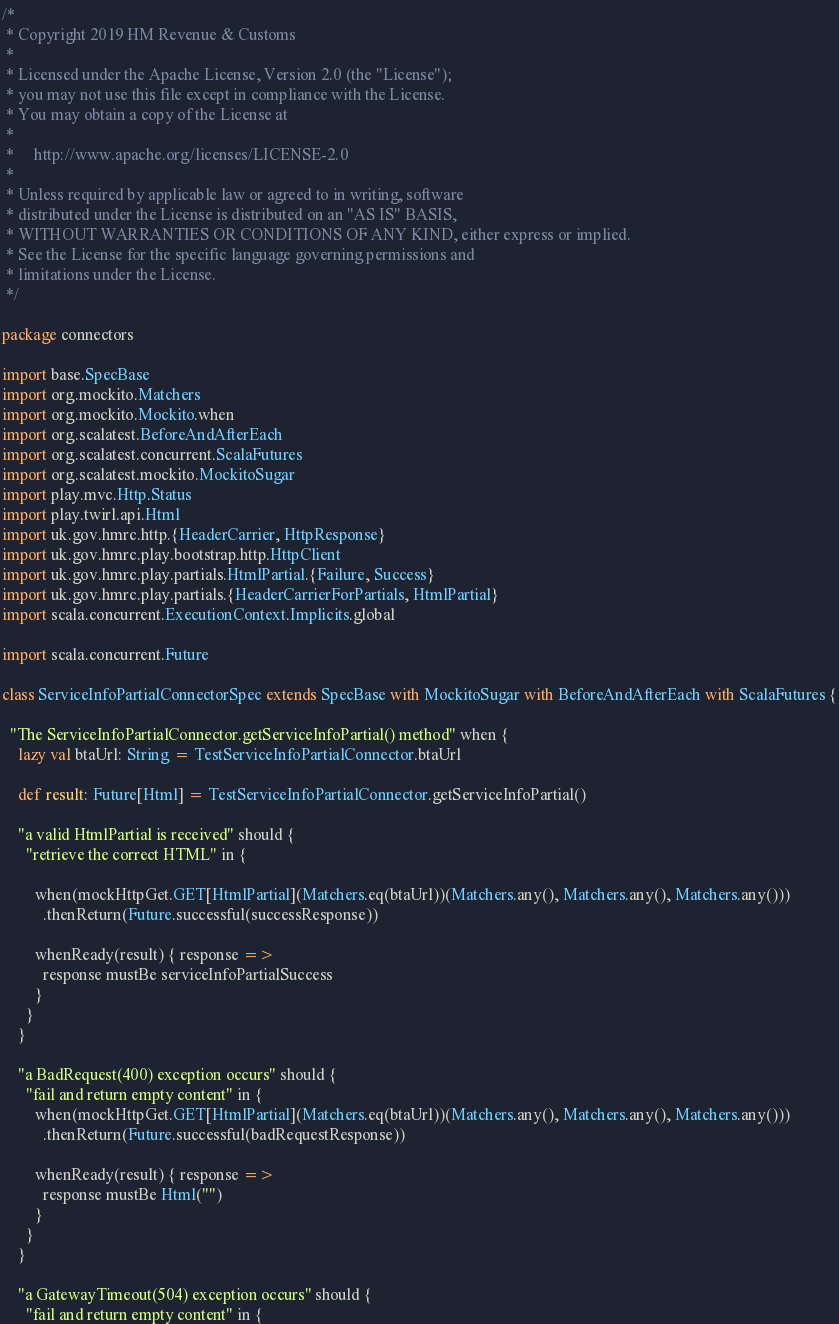<code> <loc_0><loc_0><loc_500><loc_500><_Scala_>/*
 * Copyright 2019 HM Revenue & Customs
 *
 * Licensed under the Apache License, Version 2.0 (the "License");
 * you may not use this file except in compliance with the License.
 * You may obtain a copy of the License at
 *
 *     http://www.apache.org/licenses/LICENSE-2.0
 *
 * Unless required by applicable law or agreed to in writing, software
 * distributed under the License is distributed on an "AS IS" BASIS,
 * WITHOUT WARRANTIES OR CONDITIONS OF ANY KIND, either express or implied.
 * See the License for the specific language governing permissions and
 * limitations under the License.
 */

package connectors

import base.SpecBase
import org.mockito.Matchers
import org.mockito.Mockito.when
import org.scalatest.BeforeAndAfterEach
import org.scalatest.concurrent.ScalaFutures
import org.scalatest.mockito.MockitoSugar
import play.mvc.Http.Status
import play.twirl.api.Html
import uk.gov.hmrc.http.{HeaderCarrier, HttpResponse}
import uk.gov.hmrc.play.bootstrap.http.HttpClient
import uk.gov.hmrc.play.partials.HtmlPartial.{Failure, Success}
import uk.gov.hmrc.play.partials.{HeaderCarrierForPartials, HtmlPartial}
import scala.concurrent.ExecutionContext.Implicits.global

import scala.concurrent.Future

class ServiceInfoPartialConnectorSpec extends SpecBase with MockitoSugar with BeforeAndAfterEach with ScalaFutures {

  "The ServiceInfoPartialConnector.getServiceInfoPartial() method" when {
    lazy val btaUrl: String = TestServiceInfoPartialConnector.btaUrl

    def result: Future[Html] = TestServiceInfoPartialConnector.getServiceInfoPartial()

    "a valid HtmlPartial is received" should {
      "retrieve the correct HTML" in {

        when(mockHttpGet.GET[HtmlPartial](Matchers.eq(btaUrl))(Matchers.any(), Matchers.any(), Matchers.any()))
          .thenReturn(Future.successful(successResponse))

        whenReady(result) { response =>
          response mustBe serviceInfoPartialSuccess
        }
      }
    }

    "a BadRequest(400) exception occurs" should {
      "fail and return empty content" in {
        when(mockHttpGet.GET[HtmlPartial](Matchers.eq(btaUrl))(Matchers.any(), Matchers.any(), Matchers.any()))
          .thenReturn(Future.successful(badRequestResponse))

        whenReady(result) { response =>
          response mustBe Html("")
        }
      }
    }

    "a GatewayTimeout(504) exception occurs" should {
      "fail and return empty content" in {</code> 